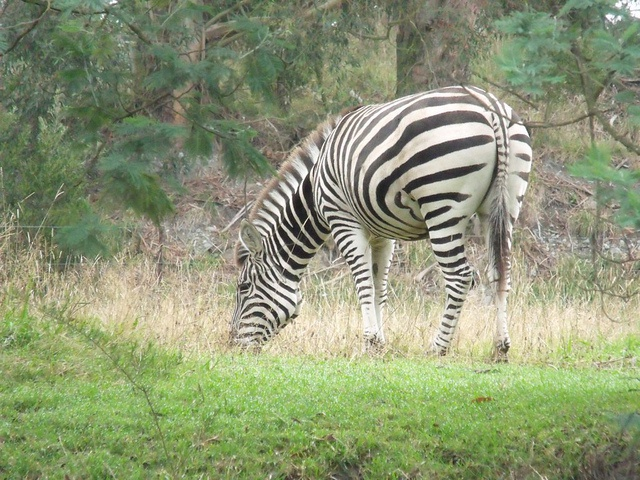Describe the objects in this image and their specific colors. I can see a zebra in gray, lightgray, darkgray, and black tones in this image. 